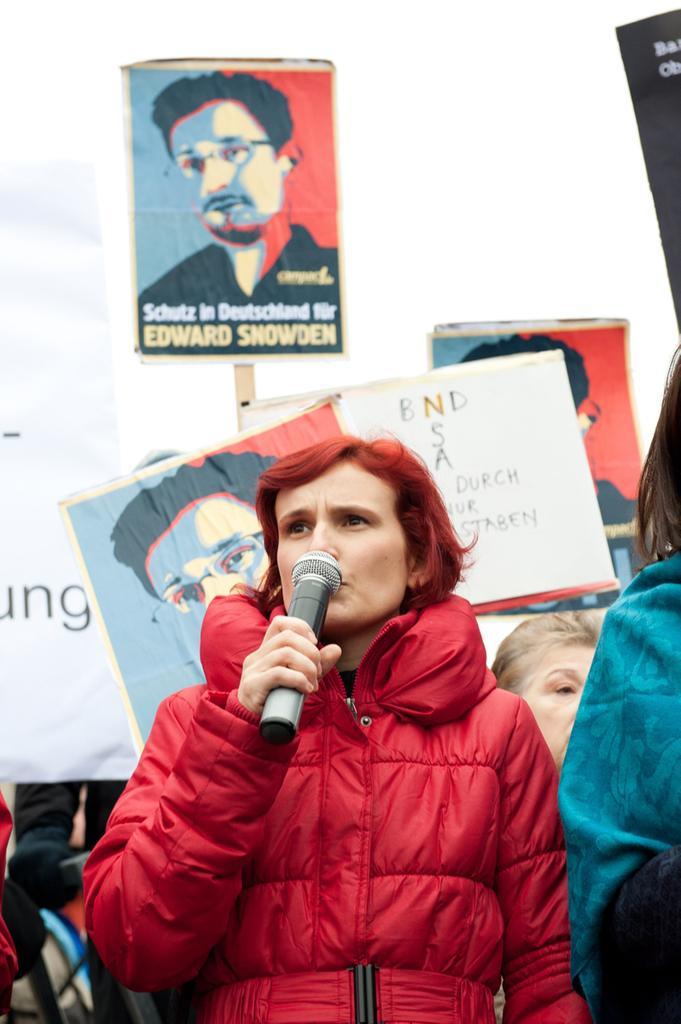How would you summarize this image in a sentence or two? In this image there is a lady person who is wearing red color raincoat holding a microphone and at the backside of the image there are quotation boards and name boards 